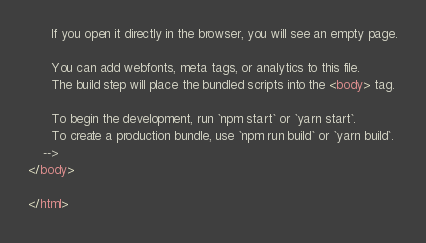Convert code to text. <code><loc_0><loc_0><loc_500><loc_500><_HTML_>      If you open it directly in the browser, you will see an empty page.

      You can add webfonts, meta tags, or analytics to this file.
      The build step will place the bundled scripts into the <body> tag.

      To begin the development, run `npm start` or `yarn start`.
      To create a production bundle, use `npm run build` or `yarn build`.
    -->
</body>

</html></code> 